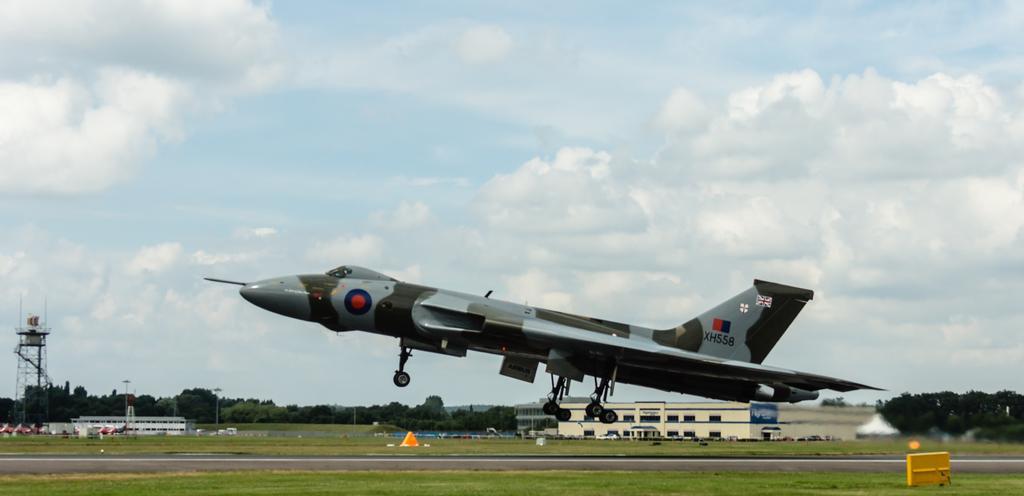Could you give a brief overview of what you see in this image? In this picture I can observe an airplane flying in the air. In the bottom of the picture I can observe runway. In the background I can observe building, trees and some clouds in the sky. 